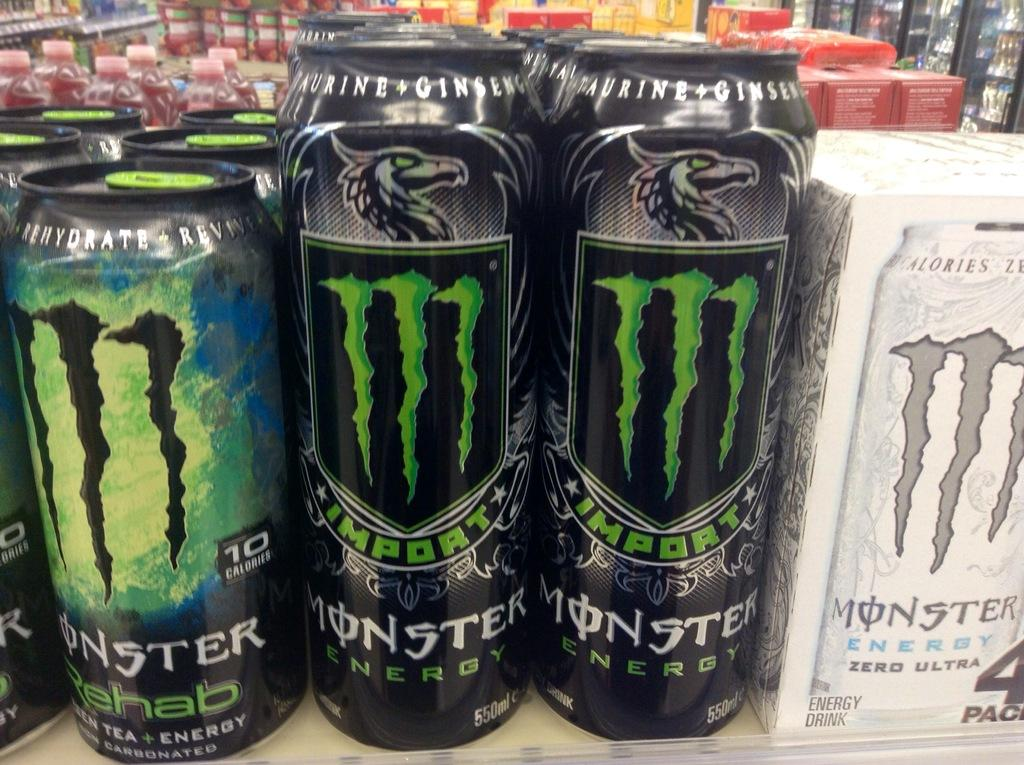<image>
Render a clear and concise summary of the photo. Some monster energy drinks with a green M on them 